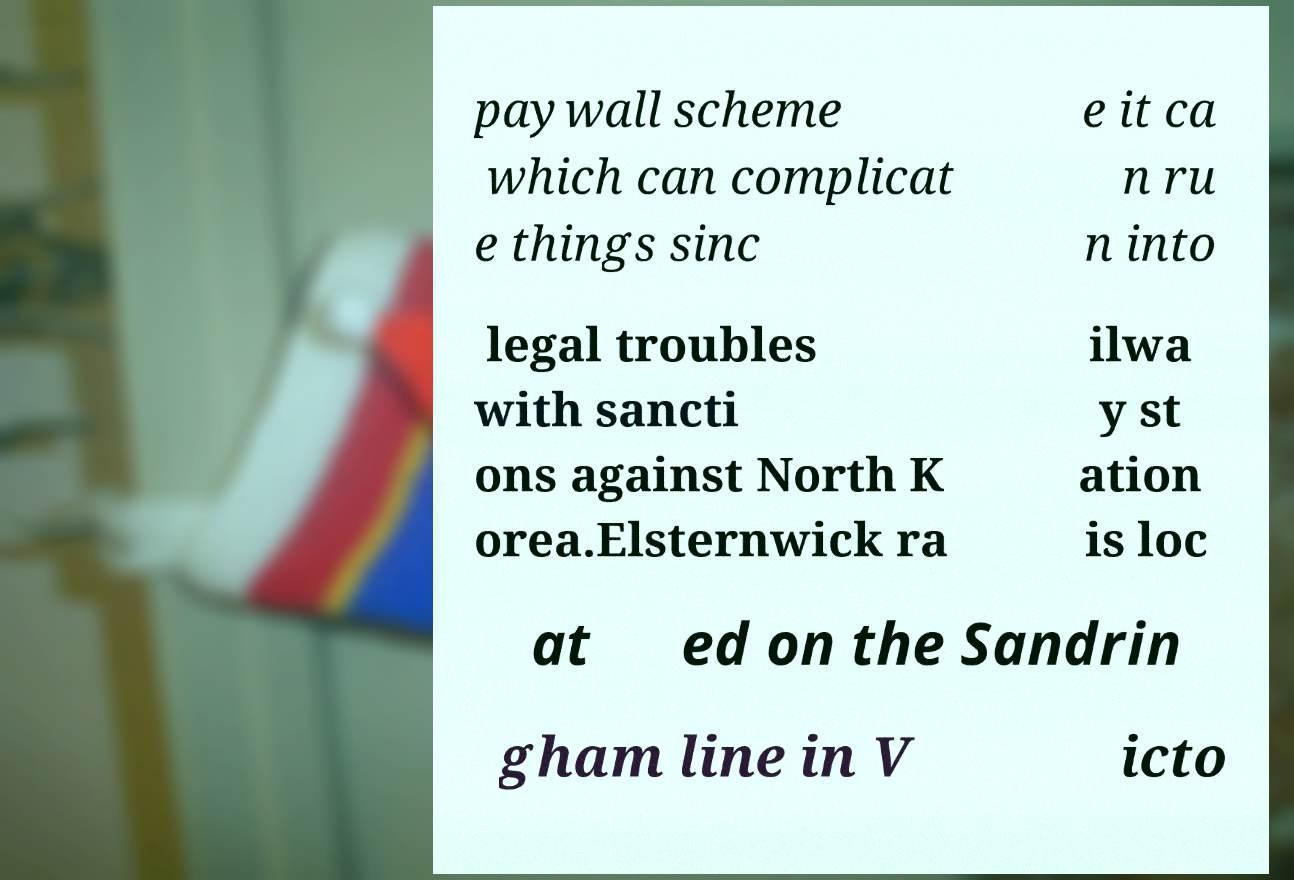For documentation purposes, I need the text within this image transcribed. Could you provide that? paywall scheme which can complicat e things sinc e it ca n ru n into legal troubles with sancti ons against North K orea.Elsternwick ra ilwa y st ation is loc at ed on the Sandrin gham line in V icto 